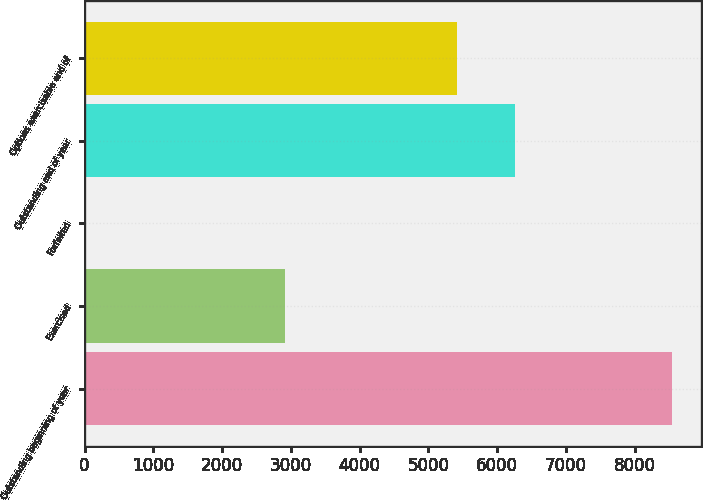<chart> <loc_0><loc_0><loc_500><loc_500><bar_chart><fcel>Outstanding beginning of year<fcel>Exercised<fcel>Forfeited<fcel>Outstanding end of year<fcel>Options exercisable end of<nl><fcel>8544<fcel>2908<fcel>14<fcel>6267<fcel>5414<nl></chart> 